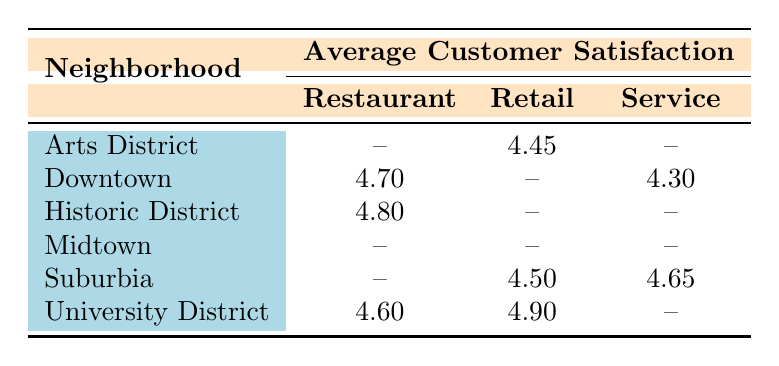What is the average customer satisfaction rating for restaurants in Downtown? The table indicates that the average customer satisfaction for restaurants in Downtown is 4.70.
Answer: 4.70 Which neighborhood has the highest average customer satisfaction rating for retail businesses? According to the table, the University District has the highest average customer satisfaction for retail businesses at 4.90.
Answer: 4.90 Is there a neighborhood that has an average customer satisfaction rating for service businesses? The table shows that both Suburbia (4.65) and Downtown (4.30) have average ratings for service businesses, confirming that the answer is yes.
Answer: Yes What is the average customer satisfaction rating for restaurants in the Historic District? The table reveals that there are no restaurant ratings listed for the Historic District, leading us to conclude that there is no average rating to provide.
Answer: -- Calculate the difference in average customer satisfaction ratings for retail businesses between the Arts District and Suburbia. The average for the Arts District is 4.45 and for Suburbia, it is 4.50. The difference is calculated as 4.50 - 4.45 = 0.05.
Answer: 0.05 Which category has the highest rating in the University District? The University District has a 4.60 rating for restaurants and a 4.90 rating for retail, making the retail category the highest.
Answer: Retail Is Harmony Yoga Studio the local favorite in its neighborhood? The table indicates that Harmony Yoga Studio is not marked as a local favorite, which answers the question as no.
Answer: No What portions of neighborhoods do not have any ratings for service businesses? An examination of the table shows that the Historic District and the University District have no average ratings listed for service businesses, confirming that neither has ratings for this category.
Answer: Historic District, University District 